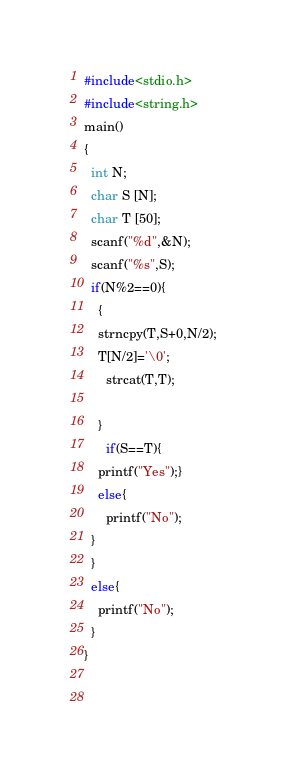<code> <loc_0><loc_0><loc_500><loc_500><_C_>#include<stdio.h>
#include<string.h>
main()
{
  int N;
  char S [N];
  char T [50];
  scanf("%d",&N);
  scanf("%s",S);
  if(N%2==0){
    {
    strncpy(T,S+0,N/2);
    T[N/2]='\0';
      strcat(T,T);
     
    }
      if(S==T){
    printf("Yes");}
    else{
      printf("No");
  }
  }
  else{
    printf("No");
  }
}
    
  
</code> 